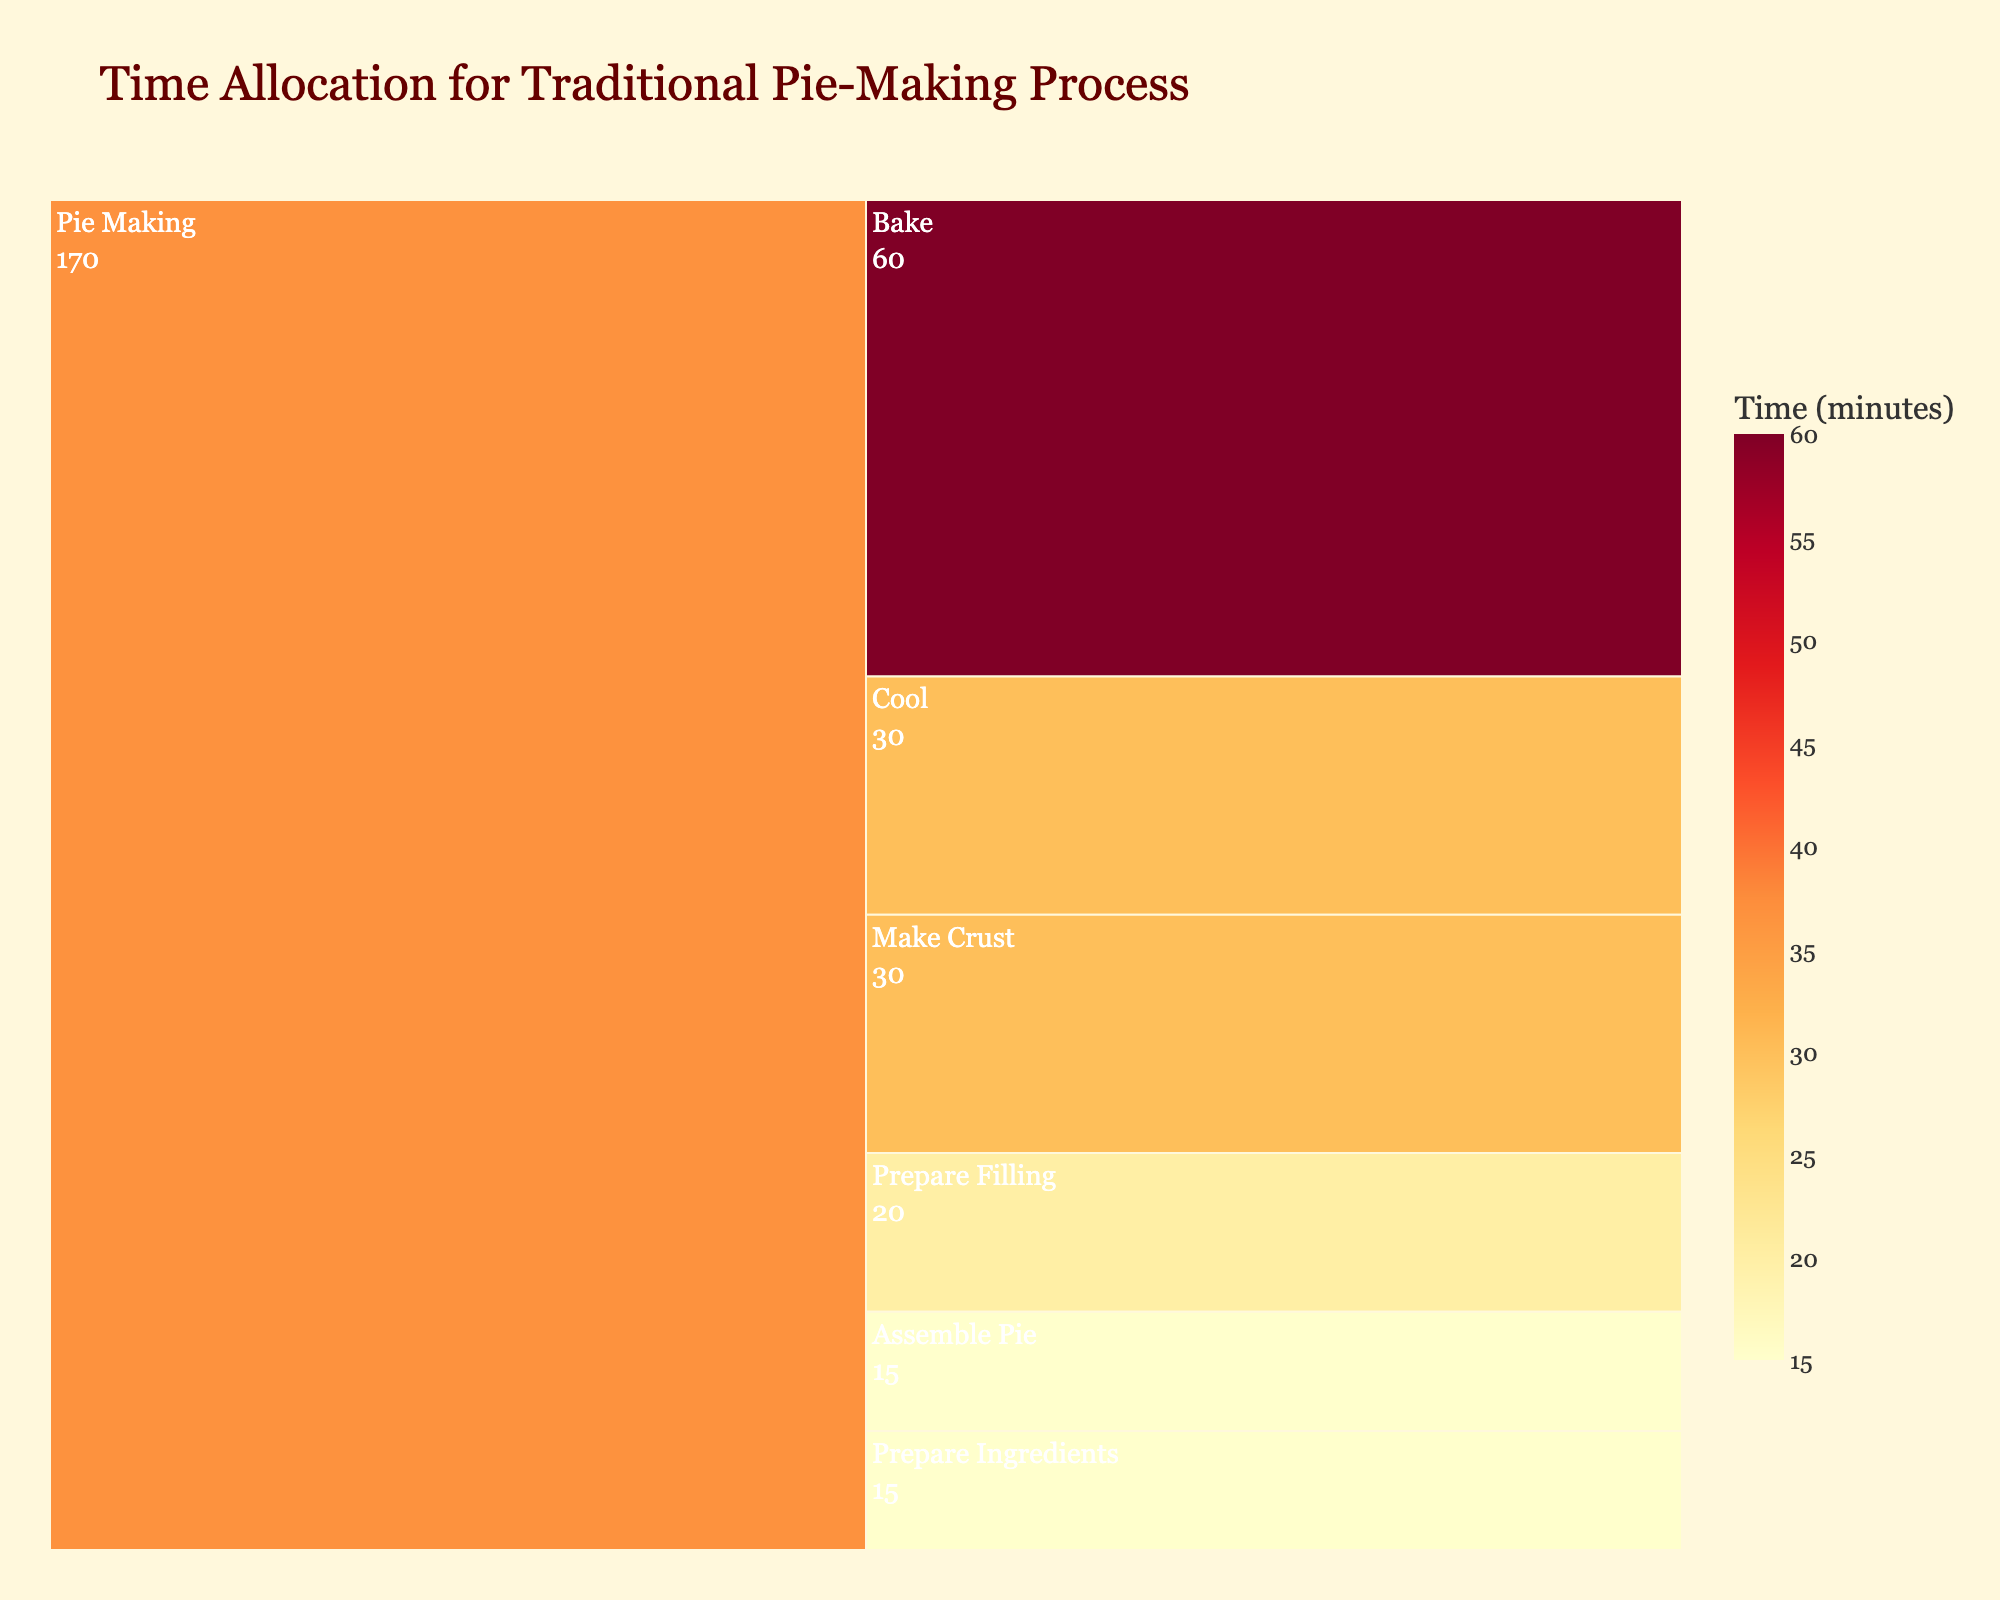What is the total time allocated for making a traditional pie? The icicle chart shows time allocated to different steps: Prepare Ingredients (15 minutes), Make Crust (30 minutes), Prepare Filling (20 minutes), Assemble Pie (15 minutes), Bake (60 minutes), Cool (30 minutes). Summing them all gives 15 + 30 + 20 + 15 + 60 + 30 = 170 minutes.
Answer: 170 minutes Which step takes the longest time in the pie-making process? Looking at the icicle chart, the step with the highest value is 'Bake' with 60 minutes.
Answer: Bake What is the total time for the steps before baking? Summing the times for 'Prepare Ingredients' (15 min), 'Make Crust' (30 min), 'Prepare Filling' (20 min), and 'Assemble Pie' (15 min): 15 + 30 + 20 + 15 = 80 minutes
Answer: 80 minutes How much more time is spent baking than cooling the pie? The time for baking is 60 minutes and for cooling is 30 minutes. The difference is 60 - 30 = 30 minutes.
Answer: 30 minutes Which steps together take up the same amount of time as baking alone? The 'Prepare Filling' (20 min) and 'Cool' (30 min) together total 50 minutes, which is less than 60 minutes. However, 'Make Crust' (30 min) and 'Assemble Pie' (15 min) add up to 45 minutes, also less. Only 'Make Crust' (30 min) and 'Prepare Filling' (20 min) together total 50 minutes. It's clear only by 5-min deviation.
Answer: 'Make Crust' and 'Prepare Filling' Which step takes the shortest time? Observing the chart, the step 'Prepare Ingredients' takes the least time with 15 minutes.
Answer: Prepare Ingredients What is the average time per step in the pie-making process? The total time is 170 minutes and there are 6 steps, so the average time per step is 170/6 ≈ 28.33 minutes.
Answer: ≈ 28.33 minutes How does the time for making the crust compare to the time for assembling the pie? 'Make Crust' takes 30 minutes and 'Assemble Pie' takes 15 minutes, so making the crust takes twice as long as assembling the pie.
Answer: Twice as long Which steps take the same amount of time? From the icicle chart, 'Prepare Ingredients' and 'Assemble Pie' both take 15 minutes.
Answer: 'Prepare Ingredients' and 'Assemble Pie' What percentage of the total pie-making time is spent baking? The total time is 170 minutes, and the baking takes 60 minutes. The percentage is (60/170) * 100 ≈ 35.29%.
Answer: ≈ 35.29% 